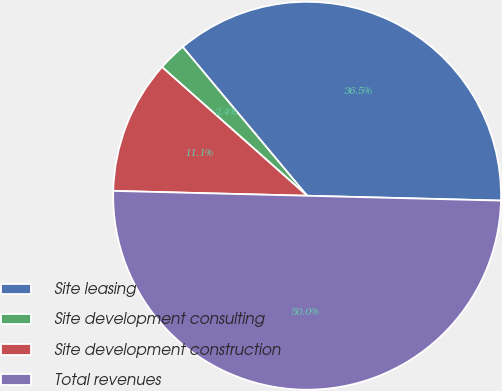<chart> <loc_0><loc_0><loc_500><loc_500><pie_chart><fcel>Site leasing<fcel>Site development consulting<fcel>Site development construction<fcel>Total revenues<nl><fcel>36.48%<fcel>2.37%<fcel>11.15%<fcel>50.0%<nl></chart> 